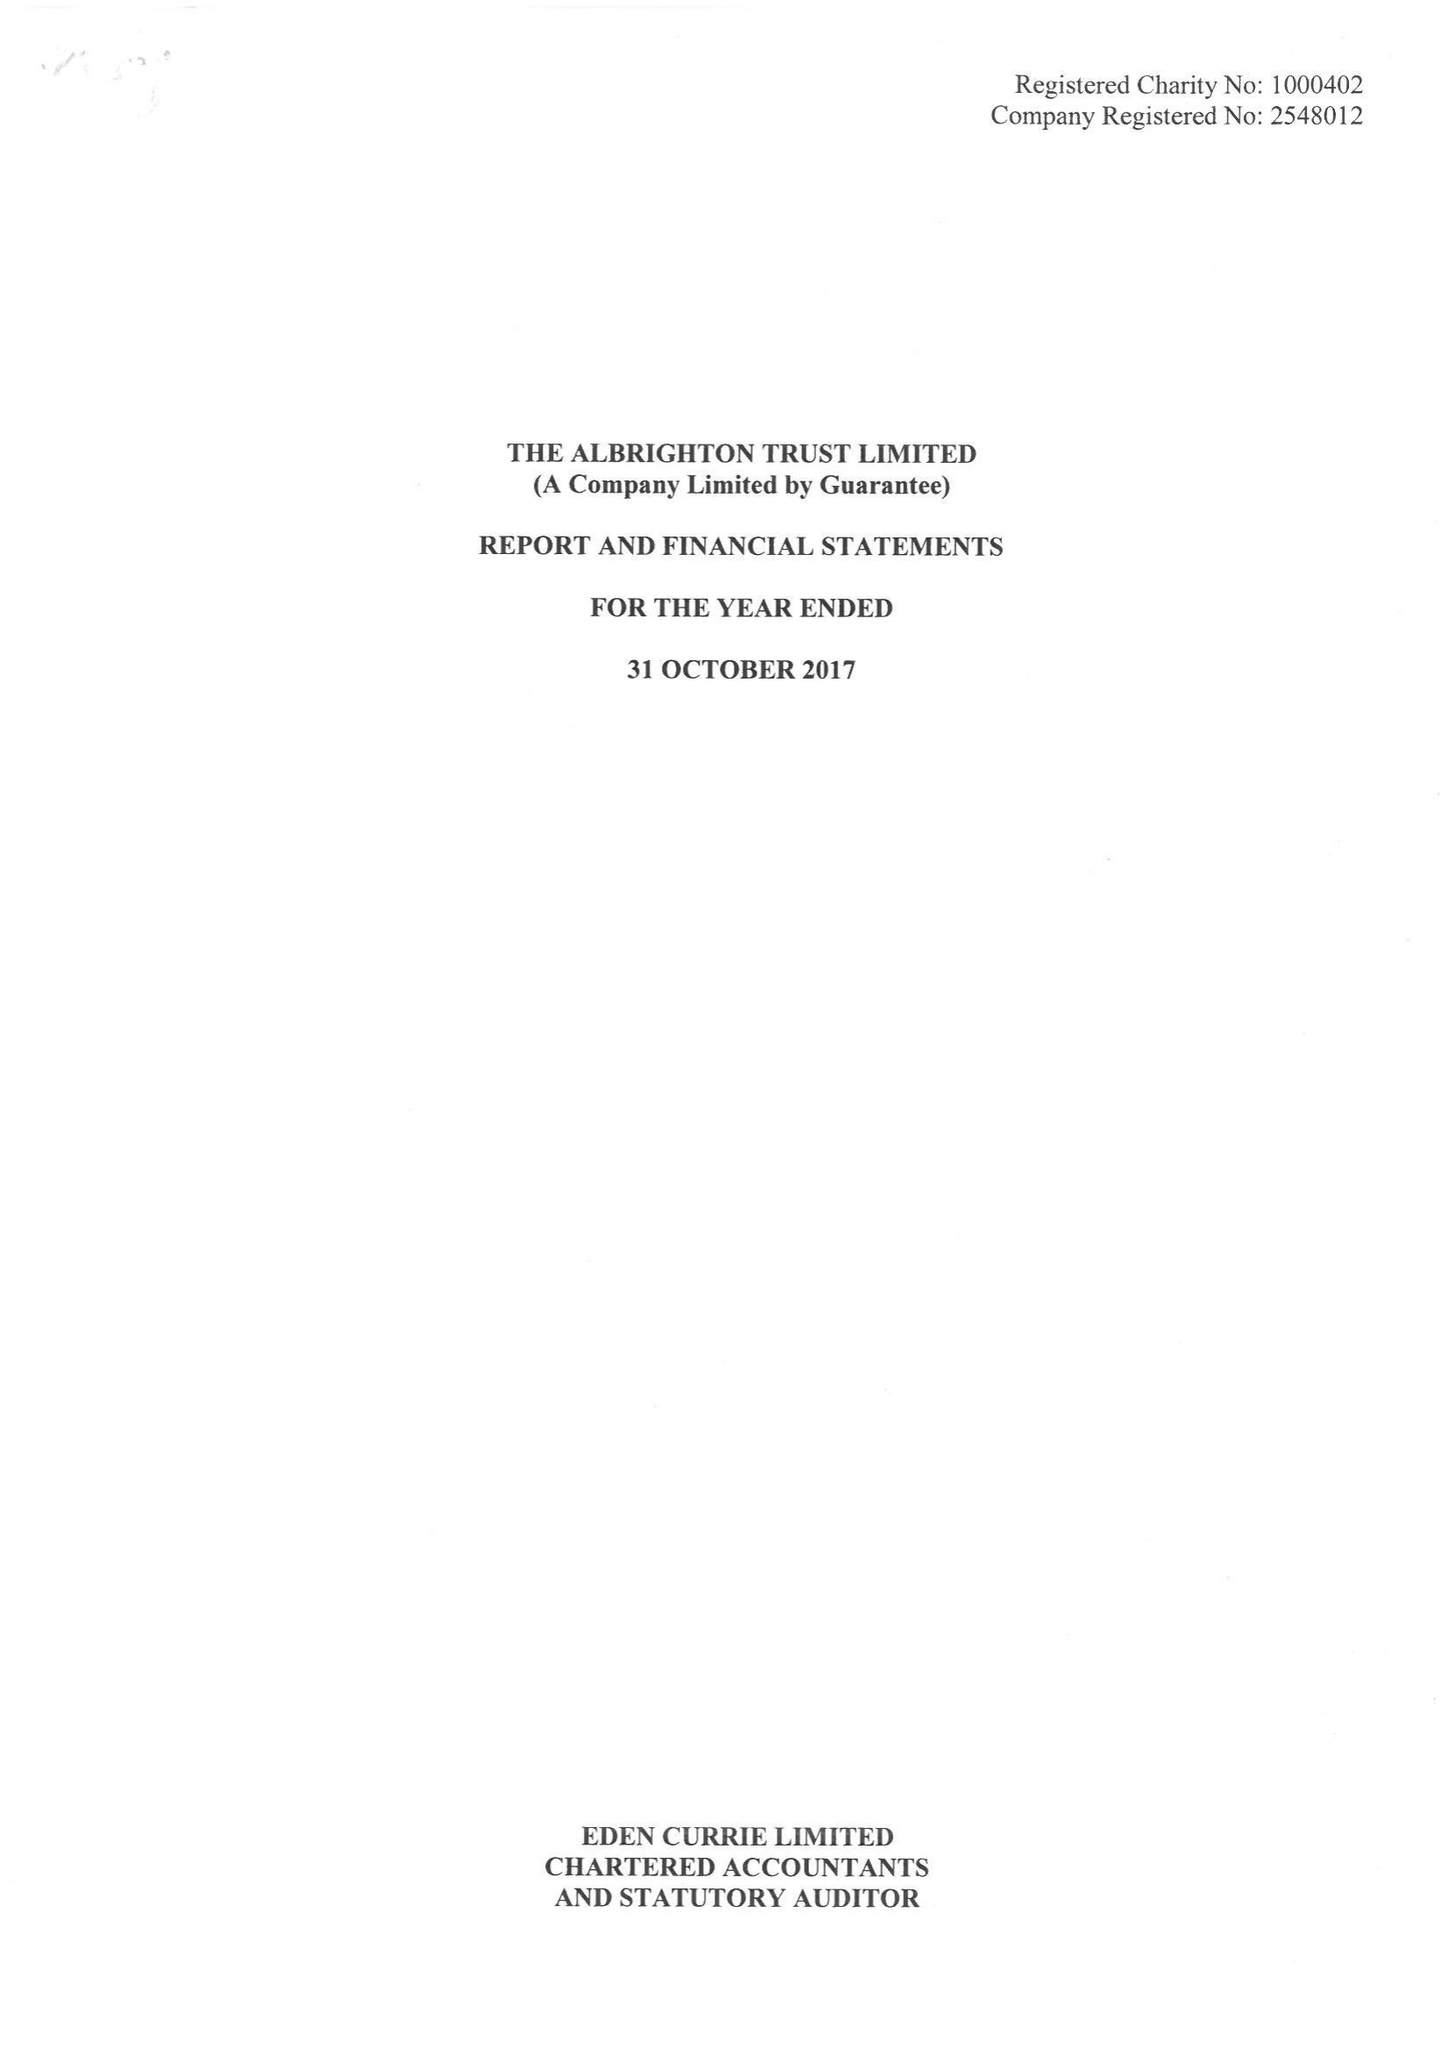What is the value for the charity_name?
Answer the question using a single word or phrase. The Albrighton Trust Ltd. 